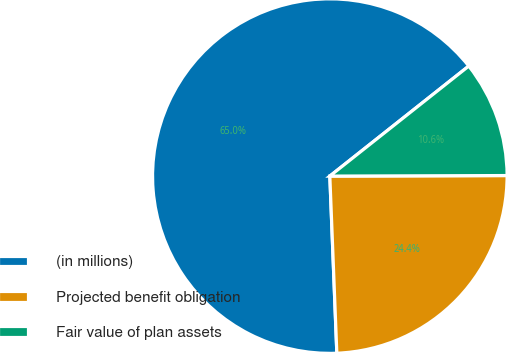<chart> <loc_0><loc_0><loc_500><loc_500><pie_chart><fcel>(in millions)<fcel>Projected benefit obligation<fcel>Fair value of plan assets<nl><fcel>64.97%<fcel>24.42%<fcel>10.61%<nl></chart> 